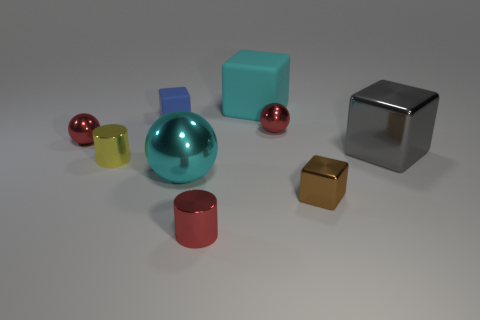Subtract all brown shiny blocks. How many blocks are left? 3 Subtract all cyan spheres. How many spheres are left? 2 Add 9 purple objects. How many purple objects exist? 9 Subtract 0 yellow blocks. How many objects are left? 9 Subtract all cubes. How many objects are left? 5 Subtract 2 spheres. How many spheres are left? 1 Subtract all yellow balls. Subtract all gray cylinders. How many balls are left? 3 Subtract all brown cubes. How many yellow balls are left? 0 Subtract all large shiny blocks. Subtract all brown cubes. How many objects are left? 7 Add 5 tiny cylinders. How many tiny cylinders are left? 7 